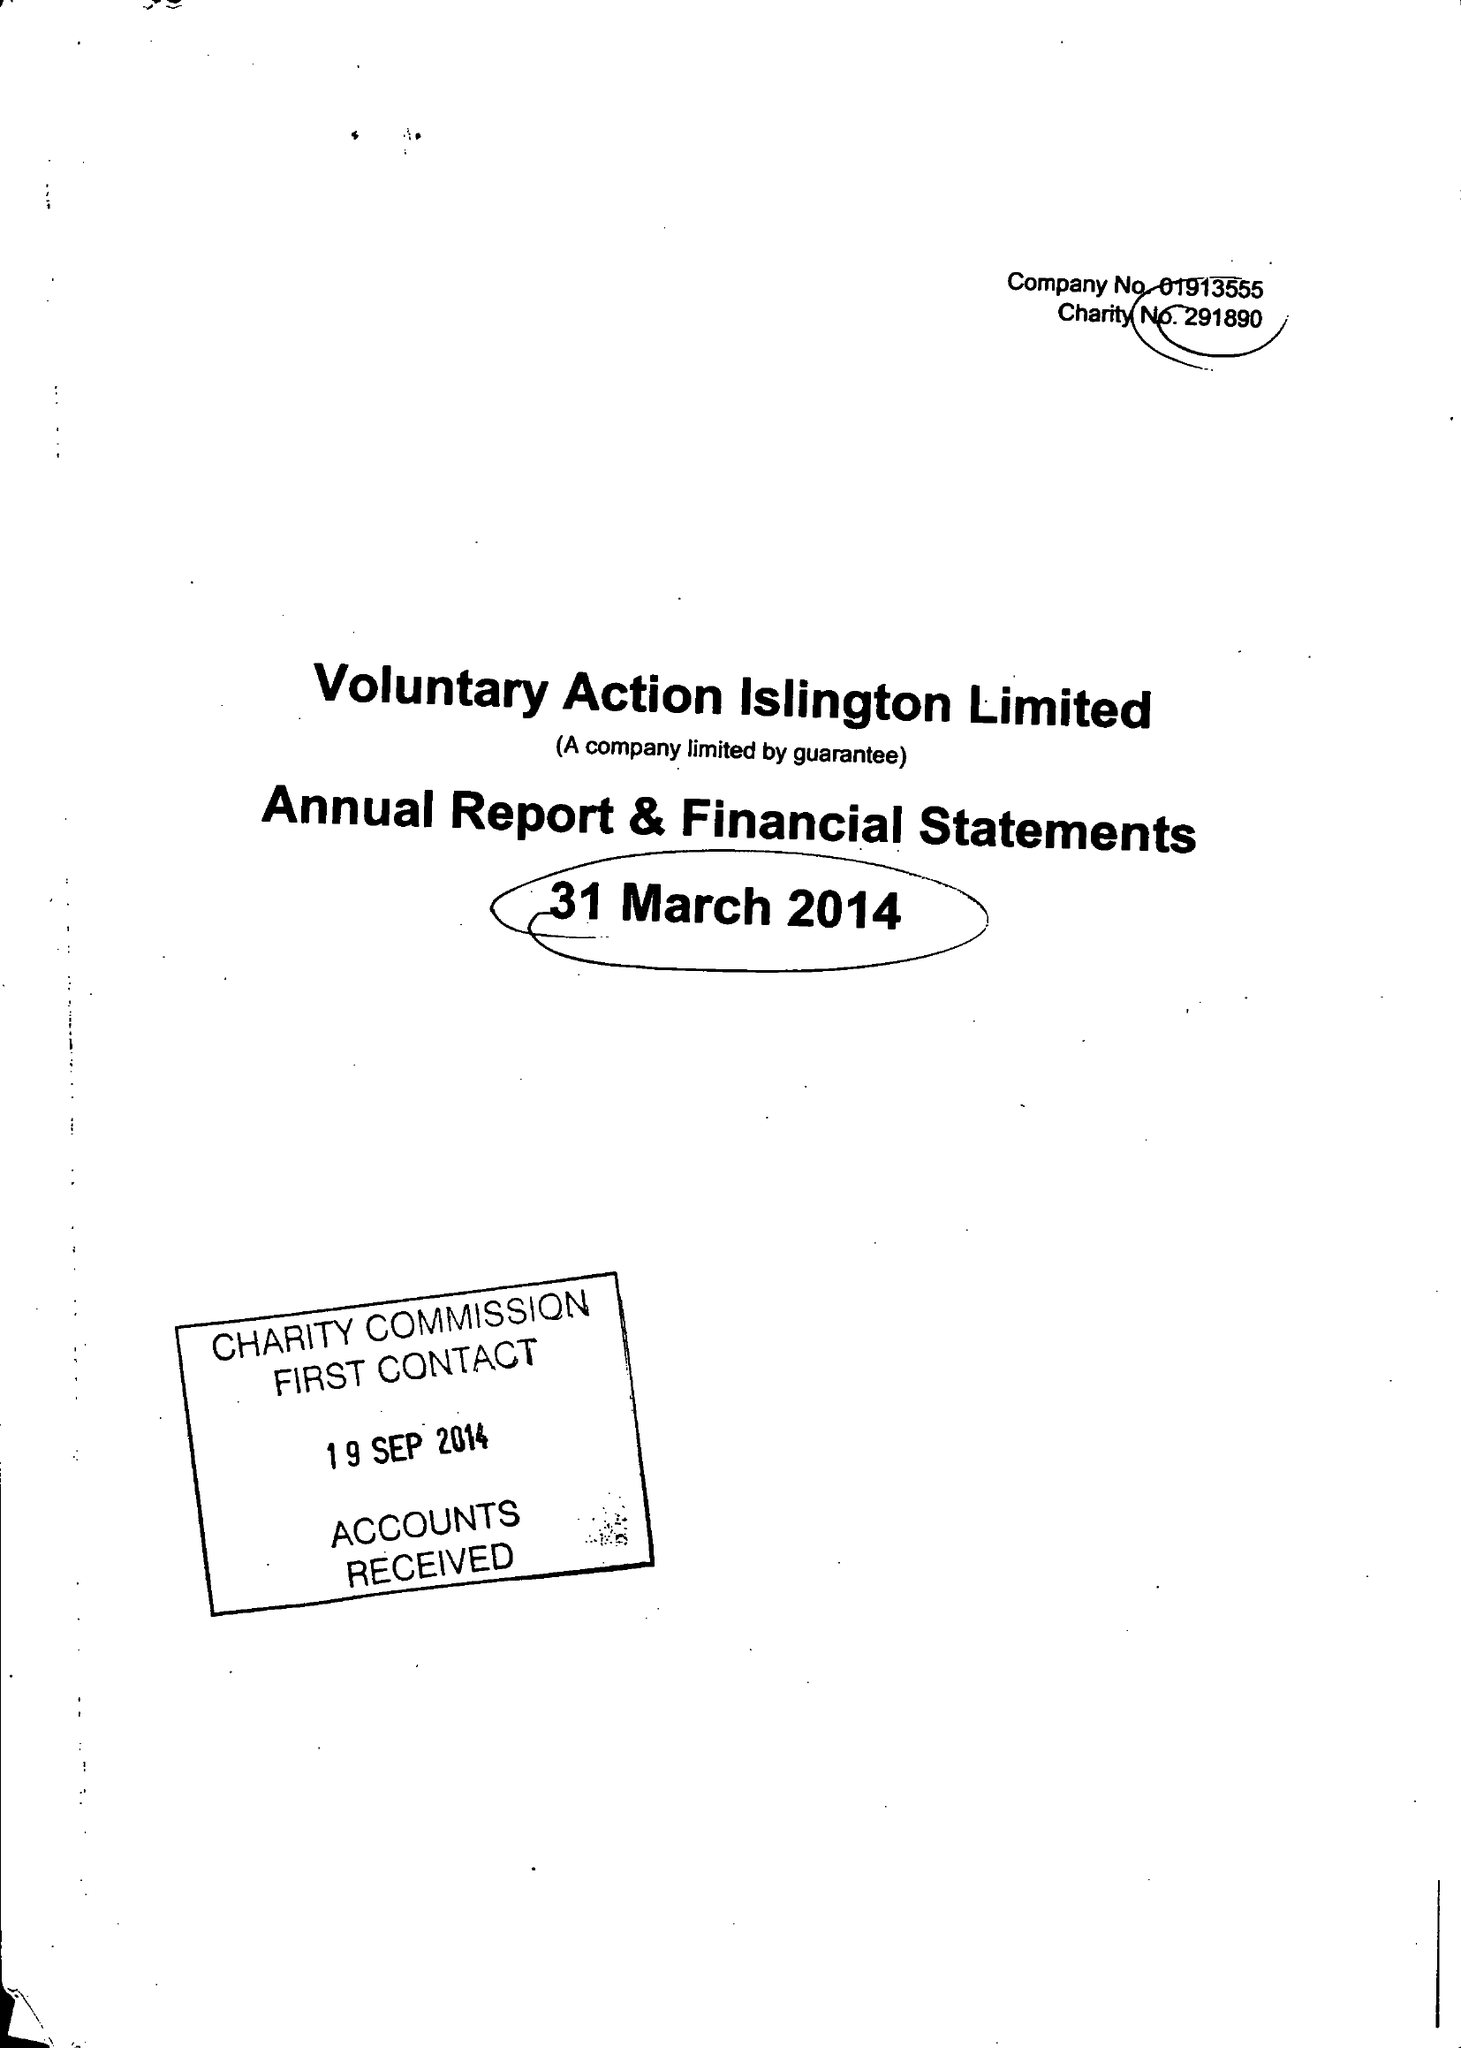What is the value for the address__street_line?
Answer the question using a single word or phrase. 200A PENTONVILLE ROAD 